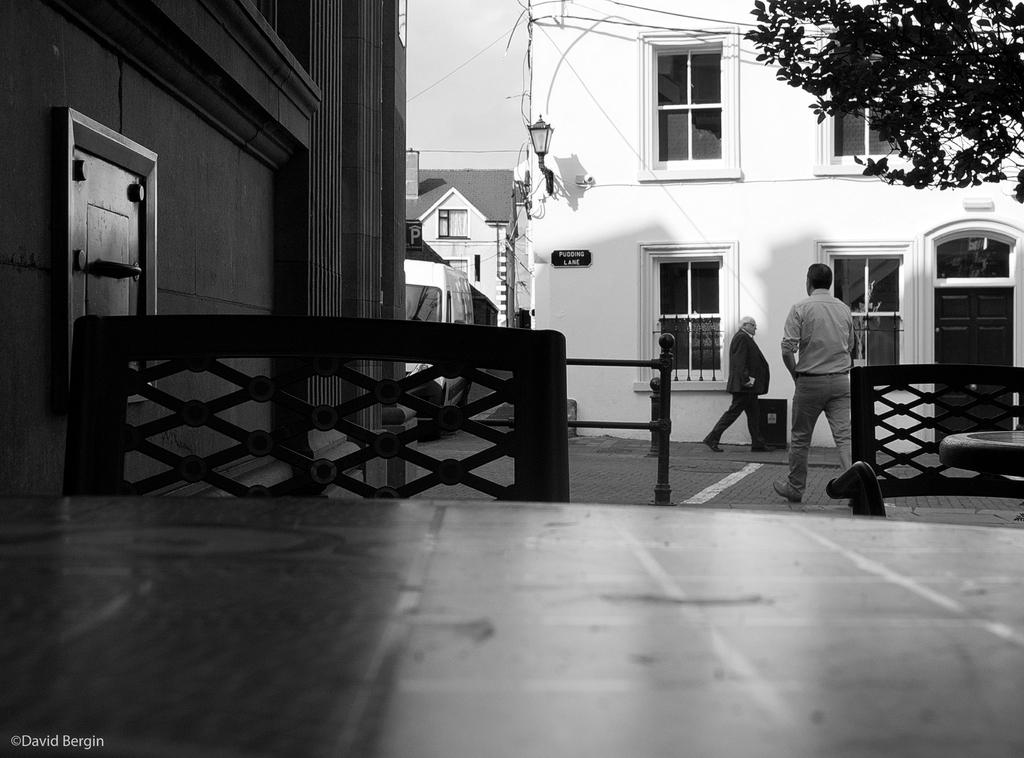What is the main subject in the center of the image? There are buildings in the center of the image. Where are the people located in the image? The people are on the right side of the image. What type of vegetation can be seen in the top right side of the image? There is a tree in the top right side of the image. What is the length of the chin of the person on the right side of the image? There is no person's chin visible in the image, as it only shows buildings, people, and a tree. Can you describe the back of the tree in the top right side of the image? The image does not provide enough detail to describe the back of the tree, as it only shows the tree's presence in the top right side of the image. 